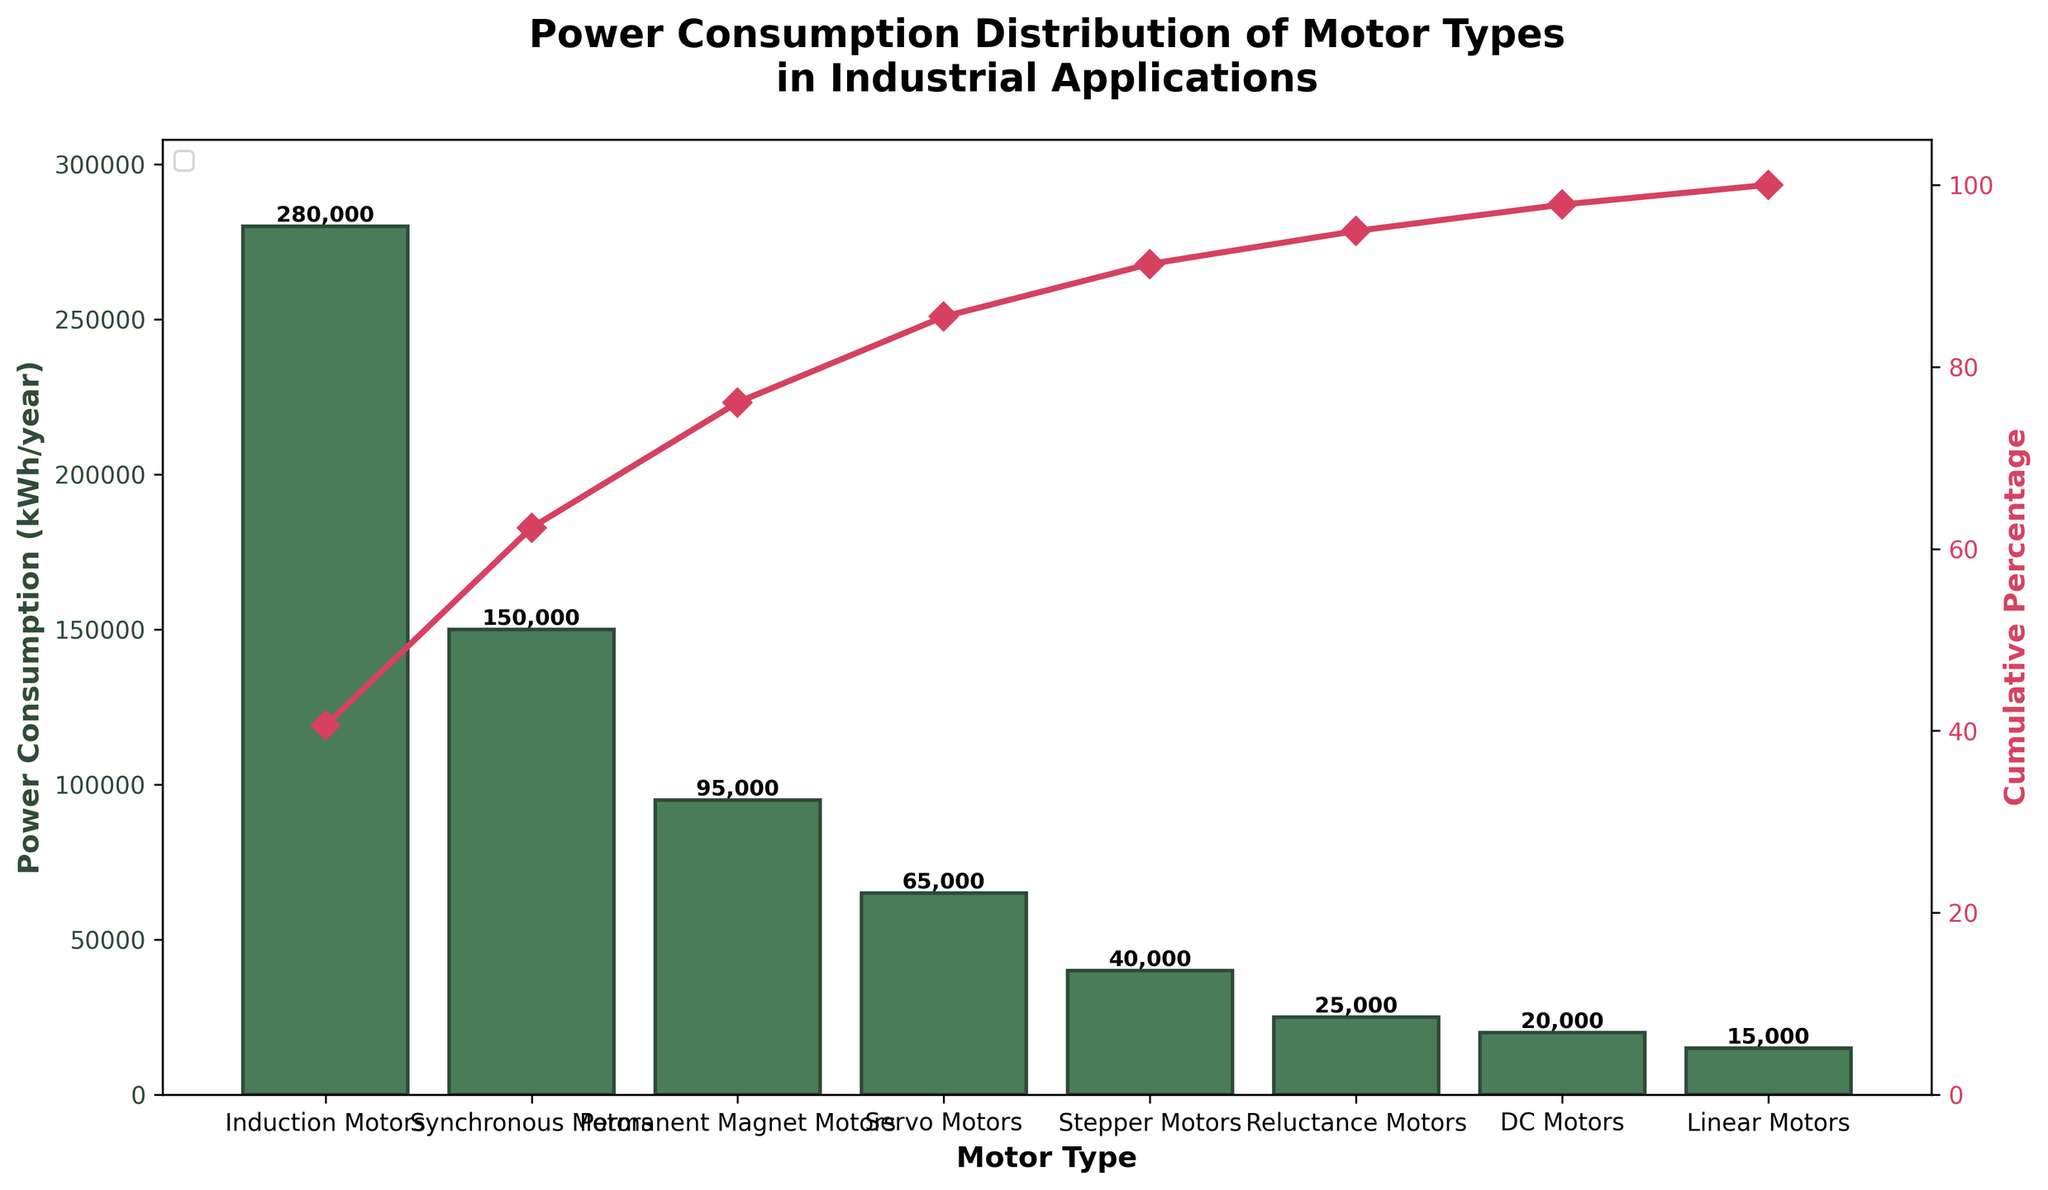What is the title of the chart? The title can be found at the top of the chart. In this case, it reads "Power Consumption Distribution of Motor Types in Industrial Applications".
Answer: Power Consumption Distribution of Motor Types in Industrial Applications Which motor type has the highest power consumption? You can identify the highest power consumption by finding the tallest bar in the bar chart. It belongs to Induction Motors.
Answer: Induction Motors What is the power consumption of Permanent Magnet Motors? Locate the bar for Permanent Magnet Motors on the x-axis and read the value corresponding to its height on the primary y-axis. It is 95,000 kWh/year.
Answer: 95,000 kWh/year Which two motor types together account for approximately 50% of the cumulative power consumption? By examining the line plot for the cumulative percentage, identify the point where the cumulative percentage is about 50%. The first two motor types, Induction Motors and Synchronous Motors, sum up to about 430,000 kWh/year, which roughly corresponds to 50% of the total power consumption.
Answer: Induction Motors and Synchronous Motors What is the total power consumption of all motor types combined? The total power consumption can be calculated by summing the power consumption values of all motor types. Adding the given values: 280,000 + 150,000 + 95,000 + 65,000 + 40,000 + 25,000 + 20,000 + 15,000, we get 690,000 kWh/year.
Answer: 690,000 kWh/year Which motor type consumes less power: Servo Motors or Stepper Motors? Compare the height of the bars corresponding to Servo Motors and Stepper Motors. The bar for Stepper Motors is shorter, indicating lower power consumption.
Answer: Stepper Motors What percentage of the cumulative power consumption is accounted for by the top three motor types? Locate the cumulative percentage value on the line plot after the third motor type (Permanent Magnet Motors). It shows around 77%.
Answer: 77% How does the power consumption of DC Motors compare to that of Linear Motors? Compare the heights of the bars for DC Motors and Linear Motors. The DC Motors bar is slightly higher, indicating that DC Motors consume more power than Linear Motors.
Answer: DC Motors have higher power consumption What is the power consumption difference between Stepper Motors and Reluctance Motors? Subtract the power consumption of Reluctance Motors from that of Stepper Motors: 40,000 kWh/year - 25,000 kWh/year = 15,000 kWh/year.
Answer: 15,000 kWh/year At what cumulative percentage does the power consumption reach 100%? The cumulative percentage reaches 100% at the last motor type on the x-axis, which aligns with the top of the secondary y-axis indicating 100%.
Answer: 100% 